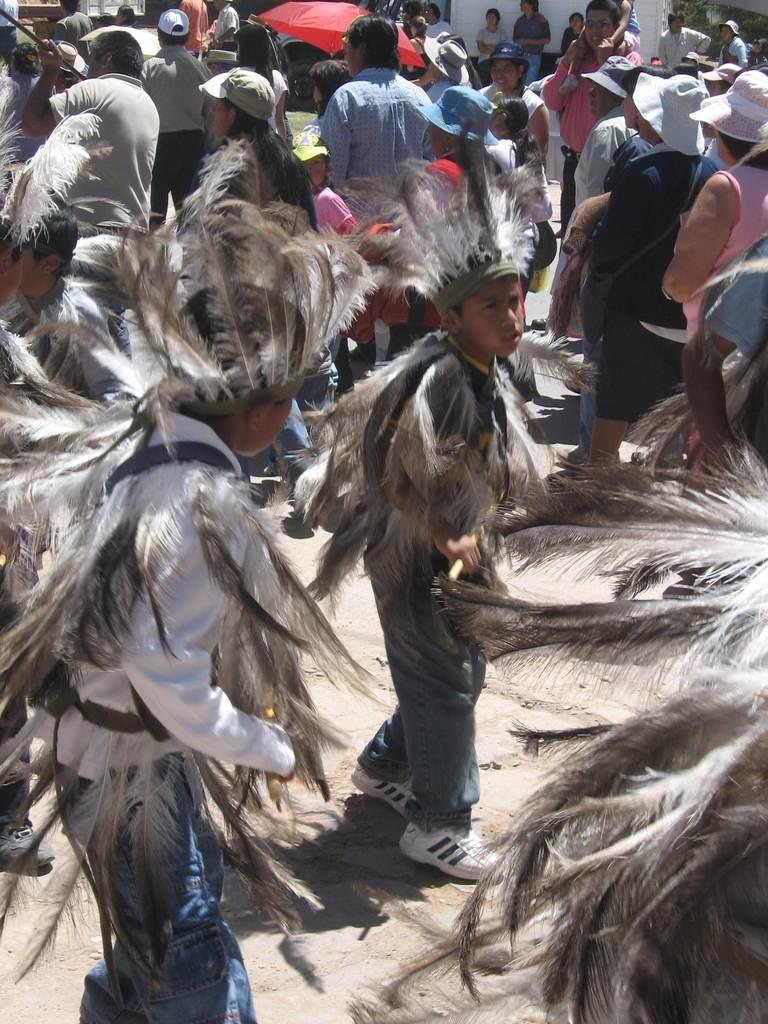How would you summarize this image in a sentence or two? In this picture we can see some people are wearing costumes. In the background of the image we can see a ground of people are standing and some of them are wearing hats. At the top of the image we can see an umbrella, wall, ground. At the bottom of the image we can see the ground. 